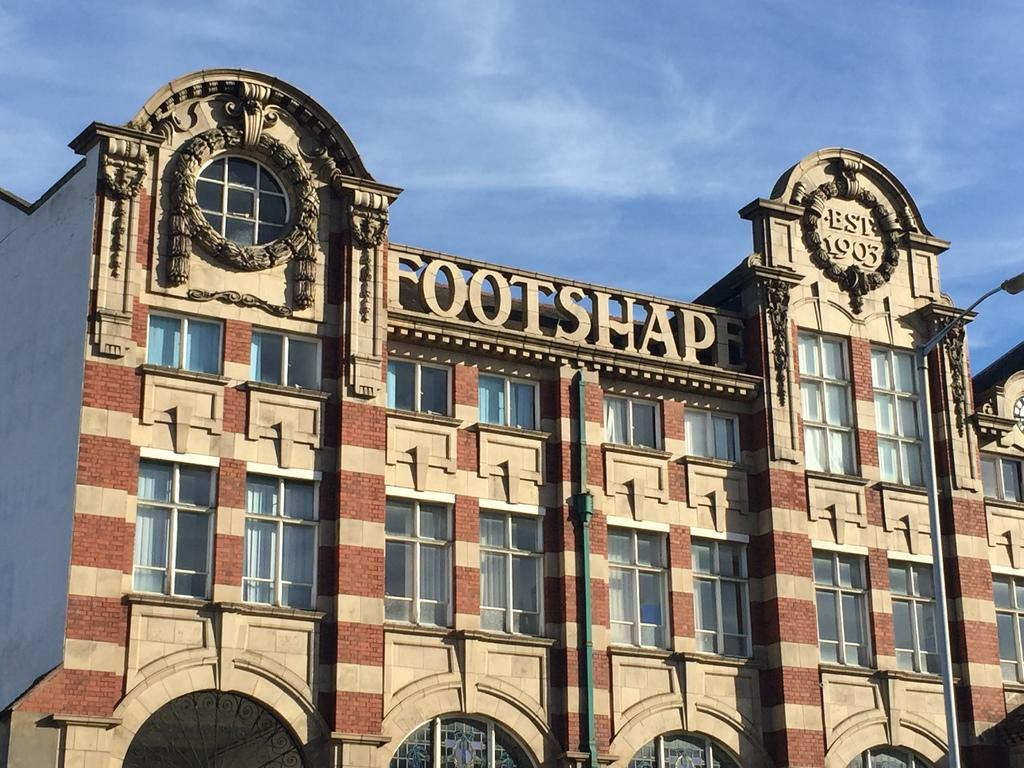What is the main subject in the center of the image? There is a building in the center of the image. What can be seen in the background of the image? The sky is visible in the background of the image. Are there any weather conditions depicted in the image? Yes, clouds are present in the background of the image. What type of pest can be seen crawling on the banana in the image? There is no banana or pest present in the image; it features a building and clouds in the sky. 